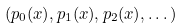Convert formula to latex. <formula><loc_0><loc_0><loc_500><loc_500>( p _ { 0 } ( x ) , p _ { 1 } ( x ) , p _ { 2 } ( x ) , \dots )</formula> 